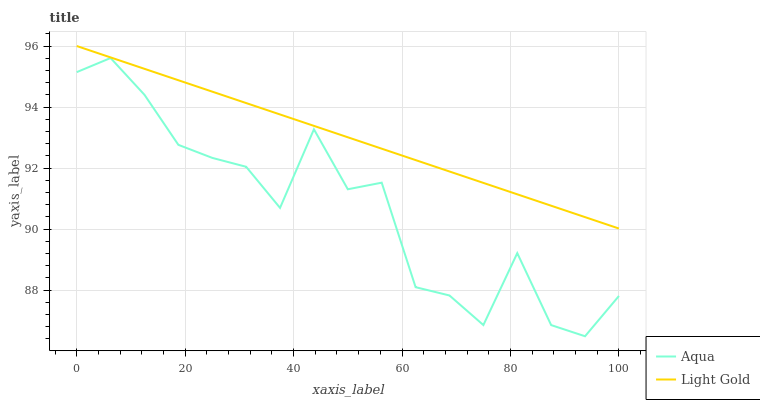Does Aqua have the maximum area under the curve?
Answer yes or no. No. Is Aqua the smoothest?
Answer yes or no. No. Does Aqua have the highest value?
Answer yes or no. No. Is Aqua less than Light Gold?
Answer yes or no. Yes. Is Light Gold greater than Aqua?
Answer yes or no. Yes. Does Aqua intersect Light Gold?
Answer yes or no. No. 